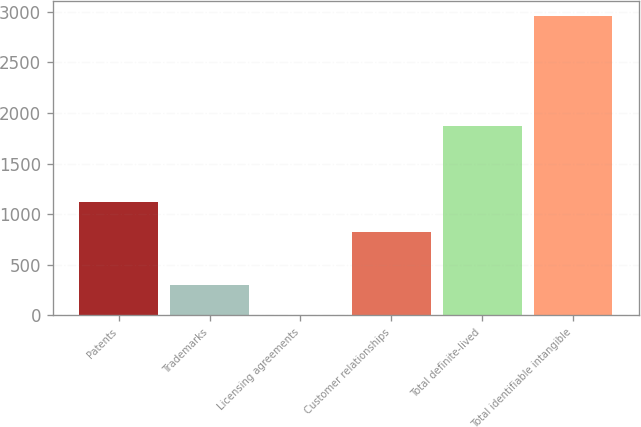Convert chart to OTSL. <chart><loc_0><loc_0><loc_500><loc_500><bar_chart><fcel>Patents<fcel>Trademarks<fcel>Licensing agreements<fcel>Customer relationships<fcel>Total definite-lived<fcel>Total identifiable intangible<nl><fcel>1118.68<fcel>301.88<fcel>6.8<fcel>823.6<fcel>1869.2<fcel>2957.6<nl></chart> 